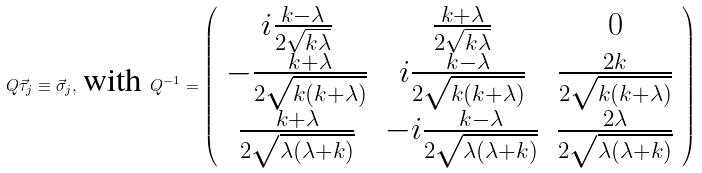<formula> <loc_0><loc_0><loc_500><loc_500>Q { \vec { \tau } } _ { j } \equiv \vec { \sigma } _ { j } , \, \text {with } Q ^ { - 1 } = \left ( \begin{array} { c c c } i \frac { k - \lambda } { 2 \sqrt { k \lambda } } & \frac { k + \lambda } { 2 \sqrt { k \lambda } } & 0 \\ - \frac { k + \lambda } { 2 \sqrt { k ( k + \lambda ) } } & i \frac { k - \lambda } { 2 \sqrt { k ( k + \lambda ) } } & \frac { 2 k } { 2 \sqrt { k ( k + \lambda ) } } \\ \frac { k + \lambda } { 2 \sqrt { \lambda ( \lambda + k ) } } & - i \frac { k - \lambda } { 2 \sqrt { \lambda ( \lambda + k ) } } & \frac { 2 \lambda } { 2 \sqrt { \lambda ( \lambda + k ) } } \end{array} \right )</formula> 